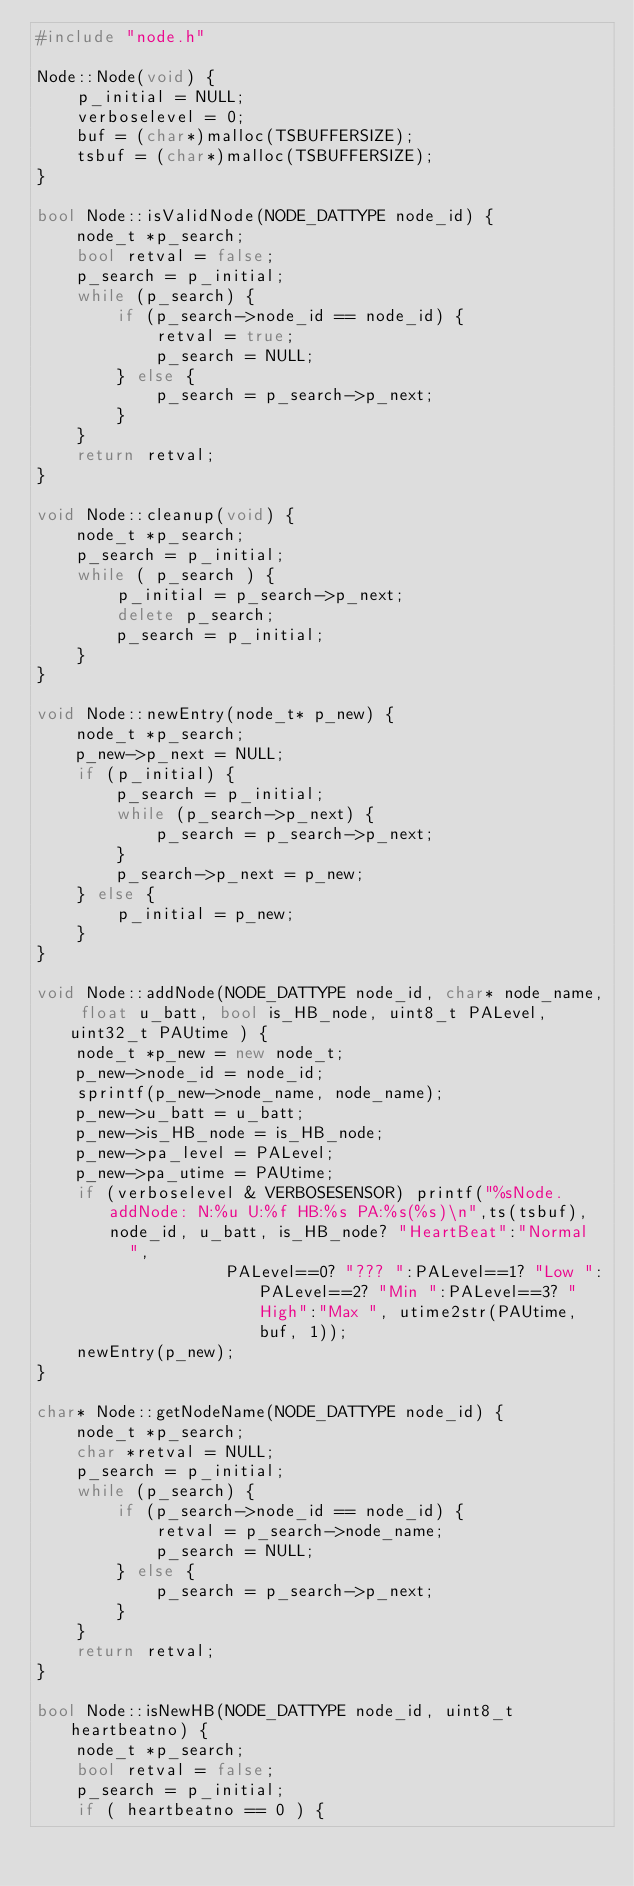Convert code to text. <code><loc_0><loc_0><loc_500><loc_500><_C++_>#include "node.h"

Node::Node(void) {
    p_initial = NULL;
    verboselevel = 0;
    buf = (char*)malloc(TSBUFFERSIZE);
    tsbuf = (char*)malloc(TSBUFFERSIZE);
}

bool Node::isValidNode(NODE_DATTYPE node_id) {
    node_t *p_search;
    bool retval = false;
    p_search = p_initial;
    while (p_search) {
        if (p_search->node_id == node_id) {
            retval = true;
            p_search = NULL;
        } else {
            p_search = p_search->p_next;
        }
    }
    return retval;
}

void Node::cleanup(void) {
    node_t *p_search;
    p_search = p_initial;
    while ( p_search ) {
        p_initial = p_search->p_next;
        delete p_search;
        p_search = p_initial;
    }
}

void Node::newEntry(node_t* p_new) {
    node_t *p_search;
    p_new->p_next = NULL;
    if (p_initial) {
        p_search = p_initial;
        while (p_search->p_next) {
            p_search = p_search->p_next;
        }
        p_search->p_next = p_new;
    } else {
        p_initial = p_new;
    }
}

void Node::addNode(NODE_DATTYPE node_id, char* node_name, float u_batt, bool is_HB_node, uint8_t PALevel, uint32_t PAUtime ) {
    node_t *p_new = new node_t;
    p_new->node_id = node_id;
    sprintf(p_new->node_name, node_name);
    p_new->u_batt = u_batt;
    p_new->is_HB_node = is_HB_node;
    p_new->pa_level = PALevel;
    p_new->pa_utime = PAUtime;
    if (verboselevel & VERBOSESENSOR) printf("%sNode.addNode: N:%u U:%f HB:%s PA:%s(%s)\n",ts(tsbuf),node_id, u_batt, is_HB_node? "HeartBeat":"Normal   ",
                   PALevel==0? "??? ":PALevel==1? "Low ":PALevel==2? "Min ":PALevel==3? "High":"Max ", utime2str(PAUtime, buf, 1));
    newEntry(p_new);
}

char* Node::getNodeName(NODE_DATTYPE node_id) {
    node_t *p_search;
    char *retval = NULL;
    p_search = p_initial;
    while (p_search) {
        if (p_search->node_id == node_id) {
            retval = p_search->node_name;
            p_search = NULL;
        } else {
            p_search = p_search->p_next;
        }
    }    
    return retval;
}

bool Node::isNewHB(NODE_DATTYPE node_id, uint8_t heartbeatno) {
    node_t *p_search;
    bool retval = false;
    p_search = p_initial;
    if ( heartbeatno == 0 ) {</code> 